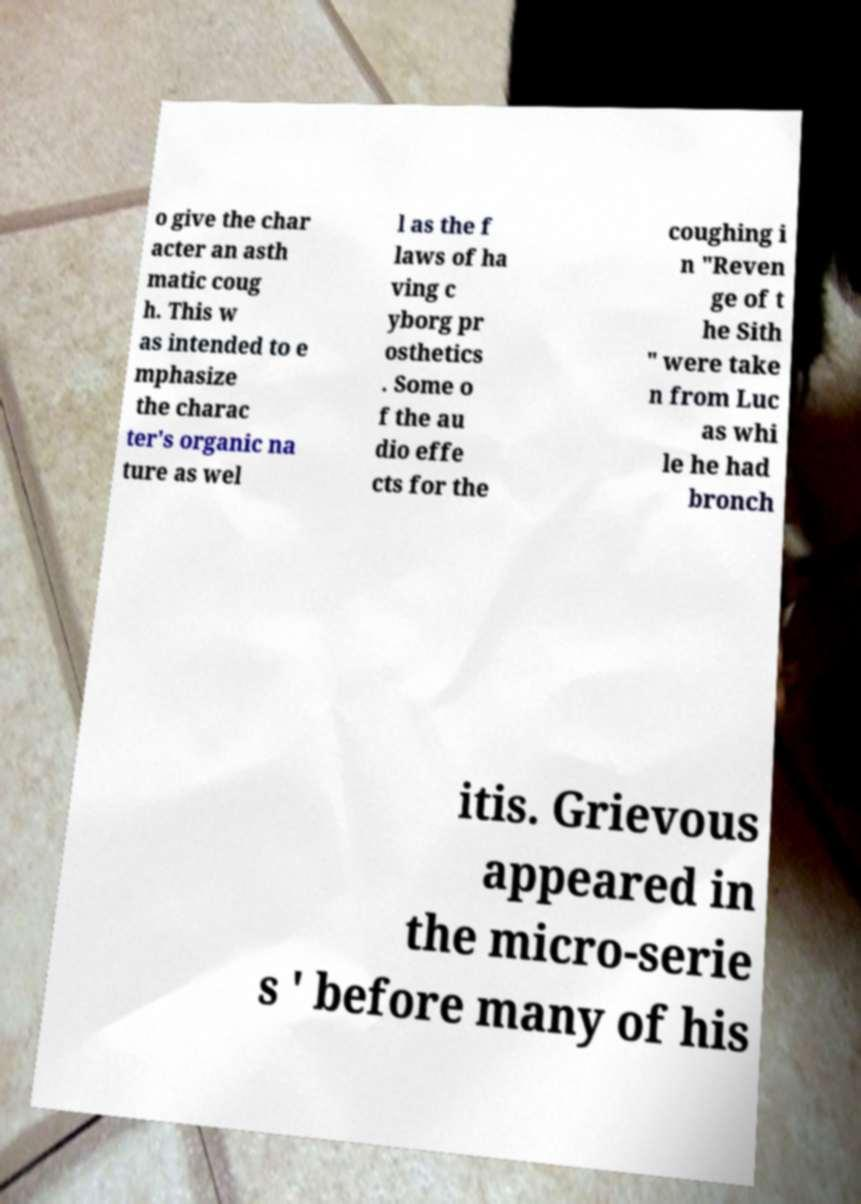Can you accurately transcribe the text from the provided image for me? o give the char acter an asth matic coug h. This w as intended to e mphasize the charac ter's organic na ture as wel l as the f laws of ha ving c yborg pr osthetics . Some o f the au dio effe cts for the coughing i n "Reven ge of t he Sith " were take n from Luc as whi le he had bronch itis. Grievous appeared in the micro-serie s ' before many of his 